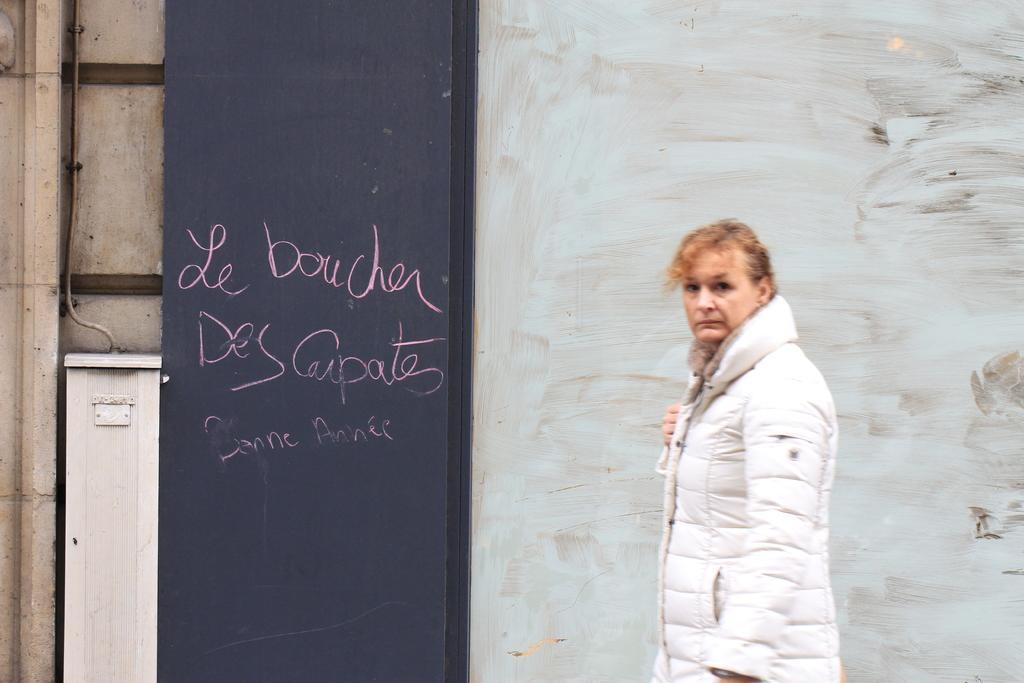Describe this image in one or two sentences. In this image I can see a woman is standing on the right side and I can see she is wearing white colour jacket. On the left side of this image I can see a white colour thing, a black colour board and on it I can see something is written. 